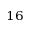Convert formula to latex. <formula><loc_0><loc_0><loc_500><loc_500>^ { 1 6 }</formula> 